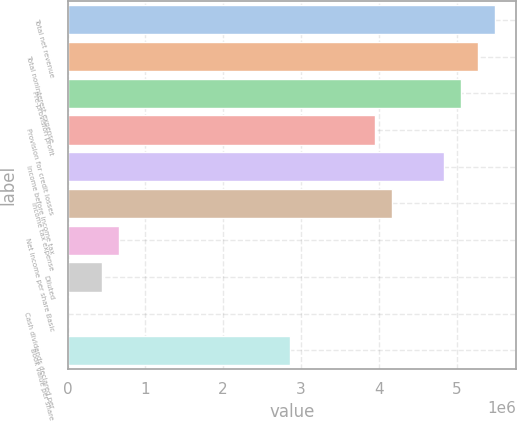<chart> <loc_0><loc_0><loc_500><loc_500><bar_chart><fcel>Total net revenue<fcel>Total noninterest expense<fcel>Pre-provision profit<fcel>Provision for credit losses<fcel>Income before income tax<fcel>Income tax expense<fcel>Net income per share Basic<fcel>Diluted<fcel>Cash dividends declared per<fcel>Book value per share<nl><fcel>5.4954e+06<fcel>5.27559e+06<fcel>5.05577e+06<fcel>3.95669e+06<fcel>4.83595e+06<fcel>4.17651e+06<fcel>659448<fcel>439632<fcel>0.25<fcel>2.85761e+06<nl></chart> 